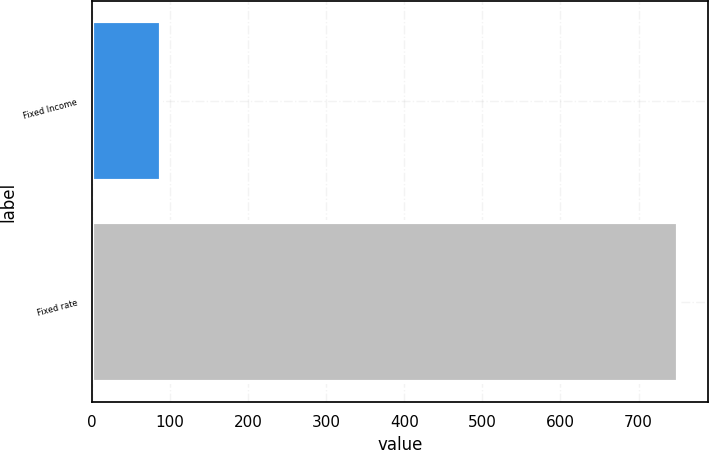Convert chart to OTSL. <chart><loc_0><loc_0><loc_500><loc_500><bar_chart><fcel>Fixed Income<fcel>Fixed rate<nl><fcel>89<fcel>751<nl></chart> 